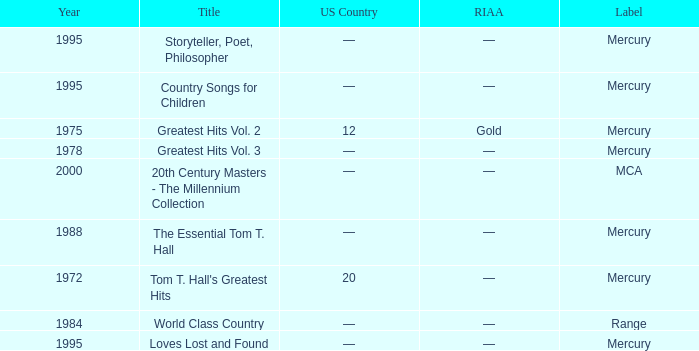What label had the album after 1978? Range, Mercury, Mercury, Mercury, Mercury, MCA. 